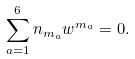Convert formula to latex. <formula><loc_0><loc_0><loc_500><loc_500>\sum _ { a = 1 } ^ { 6 } n _ { m _ { a } } w ^ { m _ { a } } = 0 .</formula> 